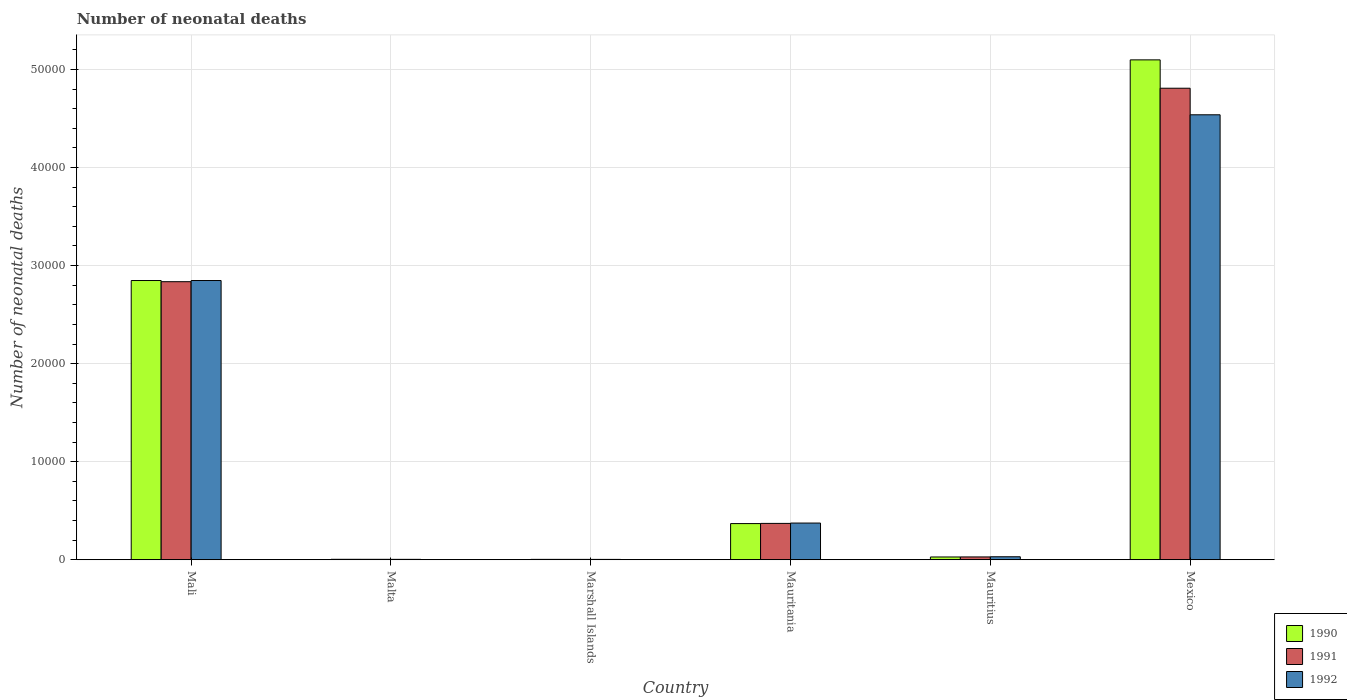How many groups of bars are there?
Your answer should be very brief. 6. Are the number of bars per tick equal to the number of legend labels?
Give a very brief answer. Yes. How many bars are there on the 2nd tick from the left?
Your answer should be very brief. 3. How many bars are there on the 4th tick from the right?
Ensure brevity in your answer.  3. What is the label of the 2nd group of bars from the left?
Give a very brief answer. Malta. In how many cases, is the number of bars for a given country not equal to the number of legend labels?
Make the answer very short. 0. What is the number of neonatal deaths in in 1991 in Malta?
Offer a terse response. 45. Across all countries, what is the maximum number of neonatal deaths in in 1990?
Offer a terse response. 5.10e+04. Across all countries, what is the minimum number of neonatal deaths in in 1991?
Keep it short and to the point. 39. In which country was the number of neonatal deaths in in 1991 minimum?
Make the answer very short. Marshall Islands. What is the total number of neonatal deaths in in 1992 in the graph?
Your response must be concise. 7.80e+04. What is the difference between the number of neonatal deaths in in 1991 in Marshall Islands and that in Mauritius?
Make the answer very short. -250. What is the difference between the number of neonatal deaths in in 1991 in Mali and the number of neonatal deaths in in 1990 in Mauritania?
Your response must be concise. 2.47e+04. What is the average number of neonatal deaths in in 1992 per country?
Provide a short and direct response. 1.30e+04. What is the difference between the number of neonatal deaths in of/in 1990 and number of neonatal deaths in of/in 1991 in Mauritania?
Keep it short and to the point. -19. What is the ratio of the number of neonatal deaths in in 1990 in Mali to that in Mauritius?
Provide a succinct answer. 99.92. Is the difference between the number of neonatal deaths in in 1990 in Mauritania and Mexico greater than the difference between the number of neonatal deaths in in 1991 in Mauritania and Mexico?
Your answer should be very brief. No. What is the difference between the highest and the second highest number of neonatal deaths in in 1992?
Give a very brief answer. 1.69e+04. What is the difference between the highest and the lowest number of neonatal deaths in in 1992?
Ensure brevity in your answer.  4.53e+04. In how many countries, is the number of neonatal deaths in in 1990 greater than the average number of neonatal deaths in in 1990 taken over all countries?
Keep it short and to the point. 2. What does the 3rd bar from the left in Marshall Islands represents?
Provide a succinct answer. 1992. Is it the case that in every country, the sum of the number of neonatal deaths in in 1991 and number of neonatal deaths in in 1990 is greater than the number of neonatal deaths in in 1992?
Your response must be concise. Yes. Are all the bars in the graph horizontal?
Give a very brief answer. No. What is the difference between two consecutive major ticks on the Y-axis?
Offer a terse response. 10000. Does the graph contain grids?
Offer a very short reply. Yes. Where does the legend appear in the graph?
Keep it short and to the point. Bottom right. How are the legend labels stacked?
Offer a very short reply. Vertical. What is the title of the graph?
Offer a very short reply. Number of neonatal deaths. What is the label or title of the Y-axis?
Your response must be concise. Number of neonatal deaths. What is the Number of neonatal deaths in 1990 in Mali?
Give a very brief answer. 2.85e+04. What is the Number of neonatal deaths of 1991 in Mali?
Give a very brief answer. 2.84e+04. What is the Number of neonatal deaths of 1992 in Mali?
Make the answer very short. 2.85e+04. What is the Number of neonatal deaths in 1992 in Malta?
Offer a very short reply. 42. What is the Number of neonatal deaths in 1990 in Marshall Islands?
Provide a short and direct response. 40. What is the Number of neonatal deaths in 1991 in Marshall Islands?
Provide a short and direct response. 39. What is the Number of neonatal deaths of 1990 in Mauritania?
Offer a very short reply. 3690. What is the Number of neonatal deaths of 1991 in Mauritania?
Keep it short and to the point. 3709. What is the Number of neonatal deaths in 1992 in Mauritania?
Provide a succinct answer. 3743. What is the Number of neonatal deaths of 1990 in Mauritius?
Your answer should be compact. 285. What is the Number of neonatal deaths in 1991 in Mauritius?
Your response must be concise. 289. What is the Number of neonatal deaths of 1992 in Mauritius?
Keep it short and to the point. 307. What is the Number of neonatal deaths in 1990 in Mexico?
Make the answer very short. 5.10e+04. What is the Number of neonatal deaths of 1991 in Mexico?
Offer a terse response. 4.81e+04. What is the Number of neonatal deaths in 1992 in Mexico?
Your answer should be compact. 4.54e+04. Across all countries, what is the maximum Number of neonatal deaths of 1990?
Ensure brevity in your answer.  5.10e+04. Across all countries, what is the maximum Number of neonatal deaths of 1991?
Your answer should be compact. 4.81e+04. Across all countries, what is the maximum Number of neonatal deaths in 1992?
Ensure brevity in your answer.  4.54e+04. Across all countries, what is the minimum Number of neonatal deaths in 1990?
Provide a succinct answer. 40. What is the total Number of neonatal deaths of 1990 in the graph?
Give a very brief answer. 8.35e+04. What is the total Number of neonatal deaths in 1991 in the graph?
Offer a very short reply. 8.05e+04. What is the total Number of neonatal deaths of 1992 in the graph?
Your response must be concise. 7.80e+04. What is the difference between the Number of neonatal deaths of 1990 in Mali and that in Malta?
Your response must be concise. 2.84e+04. What is the difference between the Number of neonatal deaths of 1991 in Mali and that in Malta?
Your answer should be compact. 2.83e+04. What is the difference between the Number of neonatal deaths in 1992 in Mali and that in Malta?
Provide a succinct answer. 2.84e+04. What is the difference between the Number of neonatal deaths in 1990 in Mali and that in Marshall Islands?
Provide a short and direct response. 2.84e+04. What is the difference between the Number of neonatal deaths of 1991 in Mali and that in Marshall Islands?
Ensure brevity in your answer.  2.83e+04. What is the difference between the Number of neonatal deaths in 1992 in Mali and that in Marshall Islands?
Your response must be concise. 2.84e+04. What is the difference between the Number of neonatal deaths in 1990 in Mali and that in Mauritania?
Offer a terse response. 2.48e+04. What is the difference between the Number of neonatal deaths in 1991 in Mali and that in Mauritania?
Provide a succinct answer. 2.46e+04. What is the difference between the Number of neonatal deaths in 1992 in Mali and that in Mauritania?
Give a very brief answer. 2.47e+04. What is the difference between the Number of neonatal deaths of 1990 in Mali and that in Mauritius?
Offer a very short reply. 2.82e+04. What is the difference between the Number of neonatal deaths of 1991 in Mali and that in Mauritius?
Offer a terse response. 2.81e+04. What is the difference between the Number of neonatal deaths in 1992 in Mali and that in Mauritius?
Make the answer very short. 2.82e+04. What is the difference between the Number of neonatal deaths of 1990 in Mali and that in Mexico?
Provide a short and direct response. -2.25e+04. What is the difference between the Number of neonatal deaths of 1991 in Mali and that in Mexico?
Provide a succinct answer. -1.97e+04. What is the difference between the Number of neonatal deaths in 1992 in Mali and that in Mexico?
Your answer should be very brief. -1.69e+04. What is the difference between the Number of neonatal deaths in 1991 in Malta and that in Marshall Islands?
Make the answer very short. 6. What is the difference between the Number of neonatal deaths in 1992 in Malta and that in Marshall Islands?
Your response must be concise. 4. What is the difference between the Number of neonatal deaths in 1990 in Malta and that in Mauritania?
Provide a succinct answer. -3643. What is the difference between the Number of neonatal deaths in 1991 in Malta and that in Mauritania?
Offer a terse response. -3664. What is the difference between the Number of neonatal deaths in 1992 in Malta and that in Mauritania?
Offer a very short reply. -3701. What is the difference between the Number of neonatal deaths of 1990 in Malta and that in Mauritius?
Ensure brevity in your answer.  -238. What is the difference between the Number of neonatal deaths in 1991 in Malta and that in Mauritius?
Ensure brevity in your answer.  -244. What is the difference between the Number of neonatal deaths of 1992 in Malta and that in Mauritius?
Your response must be concise. -265. What is the difference between the Number of neonatal deaths in 1990 in Malta and that in Mexico?
Provide a short and direct response. -5.09e+04. What is the difference between the Number of neonatal deaths in 1991 in Malta and that in Mexico?
Your answer should be very brief. -4.80e+04. What is the difference between the Number of neonatal deaths of 1992 in Malta and that in Mexico?
Your answer should be compact. -4.53e+04. What is the difference between the Number of neonatal deaths of 1990 in Marshall Islands and that in Mauritania?
Offer a terse response. -3650. What is the difference between the Number of neonatal deaths of 1991 in Marshall Islands and that in Mauritania?
Ensure brevity in your answer.  -3670. What is the difference between the Number of neonatal deaths in 1992 in Marshall Islands and that in Mauritania?
Provide a short and direct response. -3705. What is the difference between the Number of neonatal deaths in 1990 in Marshall Islands and that in Mauritius?
Your answer should be very brief. -245. What is the difference between the Number of neonatal deaths of 1991 in Marshall Islands and that in Mauritius?
Your response must be concise. -250. What is the difference between the Number of neonatal deaths of 1992 in Marshall Islands and that in Mauritius?
Give a very brief answer. -269. What is the difference between the Number of neonatal deaths in 1990 in Marshall Islands and that in Mexico?
Your response must be concise. -5.09e+04. What is the difference between the Number of neonatal deaths in 1991 in Marshall Islands and that in Mexico?
Make the answer very short. -4.80e+04. What is the difference between the Number of neonatal deaths in 1992 in Marshall Islands and that in Mexico?
Your answer should be very brief. -4.53e+04. What is the difference between the Number of neonatal deaths in 1990 in Mauritania and that in Mauritius?
Offer a very short reply. 3405. What is the difference between the Number of neonatal deaths in 1991 in Mauritania and that in Mauritius?
Provide a short and direct response. 3420. What is the difference between the Number of neonatal deaths of 1992 in Mauritania and that in Mauritius?
Keep it short and to the point. 3436. What is the difference between the Number of neonatal deaths of 1990 in Mauritania and that in Mexico?
Keep it short and to the point. -4.73e+04. What is the difference between the Number of neonatal deaths in 1991 in Mauritania and that in Mexico?
Your answer should be very brief. -4.44e+04. What is the difference between the Number of neonatal deaths in 1992 in Mauritania and that in Mexico?
Give a very brief answer. -4.16e+04. What is the difference between the Number of neonatal deaths of 1990 in Mauritius and that in Mexico?
Ensure brevity in your answer.  -5.07e+04. What is the difference between the Number of neonatal deaths of 1991 in Mauritius and that in Mexico?
Your answer should be compact. -4.78e+04. What is the difference between the Number of neonatal deaths of 1992 in Mauritius and that in Mexico?
Make the answer very short. -4.51e+04. What is the difference between the Number of neonatal deaths in 1990 in Mali and the Number of neonatal deaths in 1991 in Malta?
Offer a terse response. 2.84e+04. What is the difference between the Number of neonatal deaths in 1990 in Mali and the Number of neonatal deaths in 1992 in Malta?
Your response must be concise. 2.84e+04. What is the difference between the Number of neonatal deaths in 1991 in Mali and the Number of neonatal deaths in 1992 in Malta?
Provide a short and direct response. 2.83e+04. What is the difference between the Number of neonatal deaths of 1990 in Mali and the Number of neonatal deaths of 1991 in Marshall Islands?
Your answer should be compact. 2.84e+04. What is the difference between the Number of neonatal deaths in 1990 in Mali and the Number of neonatal deaths in 1992 in Marshall Islands?
Ensure brevity in your answer.  2.84e+04. What is the difference between the Number of neonatal deaths of 1991 in Mali and the Number of neonatal deaths of 1992 in Marshall Islands?
Make the answer very short. 2.83e+04. What is the difference between the Number of neonatal deaths in 1990 in Mali and the Number of neonatal deaths in 1991 in Mauritania?
Provide a short and direct response. 2.48e+04. What is the difference between the Number of neonatal deaths of 1990 in Mali and the Number of neonatal deaths of 1992 in Mauritania?
Provide a succinct answer. 2.47e+04. What is the difference between the Number of neonatal deaths in 1991 in Mali and the Number of neonatal deaths in 1992 in Mauritania?
Provide a succinct answer. 2.46e+04. What is the difference between the Number of neonatal deaths of 1990 in Mali and the Number of neonatal deaths of 1991 in Mauritius?
Provide a short and direct response. 2.82e+04. What is the difference between the Number of neonatal deaths of 1990 in Mali and the Number of neonatal deaths of 1992 in Mauritius?
Make the answer very short. 2.82e+04. What is the difference between the Number of neonatal deaths of 1991 in Mali and the Number of neonatal deaths of 1992 in Mauritius?
Your answer should be very brief. 2.81e+04. What is the difference between the Number of neonatal deaths of 1990 in Mali and the Number of neonatal deaths of 1991 in Mexico?
Give a very brief answer. -1.96e+04. What is the difference between the Number of neonatal deaths in 1990 in Mali and the Number of neonatal deaths in 1992 in Mexico?
Your response must be concise. -1.69e+04. What is the difference between the Number of neonatal deaths in 1991 in Mali and the Number of neonatal deaths in 1992 in Mexico?
Offer a terse response. -1.70e+04. What is the difference between the Number of neonatal deaths in 1990 in Malta and the Number of neonatal deaths in 1991 in Marshall Islands?
Your response must be concise. 8. What is the difference between the Number of neonatal deaths of 1990 in Malta and the Number of neonatal deaths of 1992 in Marshall Islands?
Your answer should be compact. 9. What is the difference between the Number of neonatal deaths of 1990 in Malta and the Number of neonatal deaths of 1991 in Mauritania?
Your answer should be very brief. -3662. What is the difference between the Number of neonatal deaths of 1990 in Malta and the Number of neonatal deaths of 1992 in Mauritania?
Give a very brief answer. -3696. What is the difference between the Number of neonatal deaths in 1991 in Malta and the Number of neonatal deaths in 1992 in Mauritania?
Offer a very short reply. -3698. What is the difference between the Number of neonatal deaths in 1990 in Malta and the Number of neonatal deaths in 1991 in Mauritius?
Your response must be concise. -242. What is the difference between the Number of neonatal deaths in 1990 in Malta and the Number of neonatal deaths in 1992 in Mauritius?
Your response must be concise. -260. What is the difference between the Number of neonatal deaths in 1991 in Malta and the Number of neonatal deaths in 1992 in Mauritius?
Give a very brief answer. -262. What is the difference between the Number of neonatal deaths of 1990 in Malta and the Number of neonatal deaths of 1991 in Mexico?
Provide a short and direct response. -4.80e+04. What is the difference between the Number of neonatal deaths in 1990 in Malta and the Number of neonatal deaths in 1992 in Mexico?
Provide a short and direct response. -4.53e+04. What is the difference between the Number of neonatal deaths of 1991 in Malta and the Number of neonatal deaths of 1992 in Mexico?
Offer a terse response. -4.53e+04. What is the difference between the Number of neonatal deaths of 1990 in Marshall Islands and the Number of neonatal deaths of 1991 in Mauritania?
Provide a short and direct response. -3669. What is the difference between the Number of neonatal deaths in 1990 in Marshall Islands and the Number of neonatal deaths in 1992 in Mauritania?
Provide a short and direct response. -3703. What is the difference between the Number of neonatal deaths of 1991 in Marshall Islands and the Number of neonatal deaths of 1992 in Mauritania?
Offer a terse response. -3704. What is the difference between the Number of neonatal deaths in 1990 in Marshall Islands and the Number of neonatal deaths in 1991 in Mauritius?
Your response must be concise. -249. What is the difference between the Number of neonatal deaths in 1990 in Marshall Islands and the Number of neonatal deaths in 1992 in Mauritius?
Provide a short and direct response. -267. What is the difference between the Number of neonatal deaths of 1991 in Marshall Islands and the Number of neonatal deaths of 1992 in Mauritius?
Ensure brevity in your answer.  -268. What is the difference between the Number of neonatal deaths in 1990 in Marshall Islands and the Number of neonatal deaths in 1991 in Mexico?
Make the answer very short. -4.80e+04. What is the difference between the Number of neonatal deaths of 1990 in Marshall Islands and the Number of neonatal deaths of 1992 in Mexico?
Provide a succinct answer. -4.53e+04. What is the difference between the Number of neonatal deaths in 1991 in Marshall Islands and the Number of neonatal deaths in 1992 in Mexico?
Give a very brief answer. -4.53e+04. What is the difference between the Number of neonatal deaths in 1990 in Mauritania and the Number of neonatal deaths in 1991 in Mauritius?
Offer a terse response. 3401. What is the difference between the Number of neonatal deaths of 1990 in Mauritania and the Number of neonatal deaths of 1992 in Mauritius?
Provide a short and direct response. 3383. What is the difference between the Number of neonatal deaths in 1991 in Mauritania and the Number of neonatal deaths in 1992 in Mauritius?
Your response must be concise. 3402. What is the difference between the Number of neonatal deaths of 1990 in Mauritania and the Number of neonatal deaths of 1991 in Mexico?
Your response must be concise. -4.44e+04. What is the difference between the Number of neonatal deaths in 1990 in Mauritania and the Number of neonatal deaths in 1992 in Mexico?
Keep it short and to the point. -4.17e+04. What is the difference between the Number of neonatal deaths in 1991 in Mauritania and the Number of neonatal deaths in 1992 in Mexico?
Your answer should be compact. -4.17e+04. What is the difference between the Number of neonatal deaths in 1990 in Mauritius and the Number of neonatal deaths in 1991 in Mexico?
Your response must be concise. -4.78e+04. What is the difference between the Number of neonatal deaths of 1990 in Mauritius and the Number of neonatal deaths of 1992 in Mexico?
Ensure brevity in your answer.  -4.51e+04. What is the difference between the Number of neonatal deaths of 1991 in Mauritius and the Number of neonatal deaths of 1992 in Mexico?
Provide a short and direct response. -4.51e+04. What is the average Number of neonatal deaths in 1990 per country?
Provide a short and direct response. 1.39e+04. What is the average Number of neonatal deaths of 1991 per country?
Your response must be concise. 1.34e+04. What is the average Number of neonatal deaths of 1992 per country?
Give a very brief answer. 1.30e+04. What is the difference between the Number of neonatal deaths of 1990 and Number of neonatal deaths of 1991 in Mali?
Ensure brevity in your answer.  120. What is the difference between the Number of neonatal deaths in 1990 and Number of neonatal deaths in 1992 in Mali?
Your answer should be very brief. 0. What is the difference between the Number of neonatal deaths of 1991 and Number of neonatal deaths of 1992 in Mali?
Ensure brevity in your answer.  -120. What is the difference between the Number of neonatal deaths of 1990 and Number of neonatal deaths of 1991 in Malta?
Offer a terse response. 2. What is the difference between the Number of neonatal deaths in 1990 and Number of neonatal deaths in 1992 in Malta?
Your response must be concise. 5. What is the difference between the Number of neonatal deaths of 1990 and Number of neonatal deaths of 1991 in Marshall Islands?
Make the answer very short. 1. What is the difference between the Number of neonatal deaths of 1990 and Number of neonatal deaths of 1991 in Mauritania?
Make the answer very short. -19. What is the difference between the Number of neonatal deaths in 1990 and Number of neonatal deaths in 1992 in Mauritania?
Your answer should be very brief. -53. What is the difference between the Number of neonatal deaths of 1991 and Number of neonatal deaths of 1992 in Mauritania?
Your answer should be compact. -34. What is the difference between the Number of neonatal deaths in 1990 and Number of neonatal deaths in 1991 in Mauritius?
Offer a terse response. -4. What is the difference between the Number of neonatal deaths in 1990 and Number of neonatal deaths in 1992 in Mauritius?
Give a very brief answer. -22. What is the difference between the Number of neonatal deaths of 1991 and Number of neonatal deaths of 1992 in Mauritius?
Your answer should be very brief. -18. What is the difference between the Number of neonatal deaths in 1990 and Number of neonatal deaths in 1991 in Mexico?
Your answer should be compact. 2892. What is the difference between the Number of neonatal deaths in 1990 and Number of neonatal deaths in 1992 in Mexico?
Provide a succinct answer. 5601. What is the difference between the Number of neonatal deaths of 1991 and Number of neonatal deaths of 1992 in Mexico?
Keep it short and to the point. 2709. What is the ratio of the Number of neonatal deaths in 1990 in Mali to that in Malta?
Keep it short and to the point. 605.91. What is the ratio of the Number of neonatal deaths of 1991 in Mali to that in Malta?
Make the answer very short. 630.18. What is the ratio of the Number of neonatal deaths of 1992 in Mali to that in Malta?
Offer a terse response. 678.05. What is the ratio of the Number of neonatal deaths of 1990 in Mali to that in Marshall Islands?
Your answer should be very brief. 711.95. What is the ratio of the Number of neonatal deaths in 1991 in Mali to that in Marshall Islands?
Your answer should be compact. 727.13. What is the ratio of the Number of neonatal deaths of 1992 in Mali to that in Marshall Islands?
Keep it short and to the point. 749.42. What is the ratio of the Number of neonatal deaths in 1990 in Mali to that in Mauritania?
Ensure brevity in your answer.  7.72. What is the ratio of the Number of neonatal deaths of 1991 in Mali to that in Mauritania?
Give a very brief answer. 7.65. What is the ratio of the Number of neonatal deaths in 1992 in Mali to that in Mauritania?
Offer a terse response. 7.61. What is the ratio of the Number of neonatal deaths of 1990 in Mali to that in Mauritius?
Your answer should be compact. 99.92. What is the ratio of the Number of neonatal deaths in 1991 in Mali to that in Mauritius?
Give a very brief answer. 98.12. What is the ratio of the Number of neonatal deaths of 1992 in Mali to that in Mauritius?
Offer a very short reply. 92.76. What is the ratio of the Number of neonatal deaths in 1990 in Mali to that in Mexico?
Offer a terse response. 0.56. What is the ratio of the Number of neonatal deaths in 1991 in Mali to that in Mexico?
Keep it short and to the point. 0.59. What is the ratio of the Number of neonatal deaths in 1992 in Mali to that in Mexico?
Offer a very short reply. 0.63. What is the ratio of the Number of neonatal deaths of 1990 in Malta to that in Marshall Islands?
Give a very brief answer. 1.18. What is the ratio of the Number of neonatal deaths in 1991 in Malta to that in Marshall Islands?
Your answer should be very brief. 1.15. What is the ratio of the Number of neonatal deaths in 1992 in Malta to that in Marshall Islands?
Your answer should be compact. 1.11. What is the ratio of the Number of neonatal deaths of 1990 in Malta to that in Mauritania?
Make the answer very short. 0.01. What is the ratio of the Number of neonatal deaths of 1991 in Malta to that in Mauritania?
Make the answer very short. 0.01. What is the ratio of the Number of neonatal deaths of 1992 in Malta to that in Mauritania?
Give a very brief answer. 0.01. What is the ratio of the Number of neonatal deaths in 1990 in Malta to that in Mauritius?
Your response must be concise. 0.16. What is the ratio of the Number of neonatal deaths in 1991 in Malta to that in Mauritius?
Offer a very short reply. 0.16. What is the ratio of the Number of neonatal deaths of 1992 in Malta to that in Mauritius?
Your answer should be compact. 0.14. What is the ratio of the Number of neonatal deaths of 1990 in Malta to that in Mexico?
Your answer should be very brief. 0. What is the ratio of the Number of neonatal deaths of 1991 in Malta to that in Mexico?
Make the answer very short. 0. What is the ratio of the Number of neonatal deaths of 1992 in Malta to that in Mexico?
Your answer should be compact. 0. What is the ratio of the Number of neonatal deaths in 1990 in Marshall Islands to that in Mauritania?
Your answer should be compact. 0.01. What is the ratio of the Number of neonatal deaths in 1991 in Marshall Islands to that in Mauritania?
Your response must be concise. 0.01. What is the ratio of the Number of neonatal deaths in 1992 in Marshall Islands to that in Mauritania?
Your answer should be very brief. 0.01. What is the ratio of the Number of neonatal deaths of 1990 in Marshall Islands to that in Mauritius?
Provide a succinct answer. 0.14. What is the ratio of the Number of neonatal deaths of 1991 in Marshall Islands to that in Mauritius?
Provide a succinct answer. 0.13. What is the ratio of the Number of neonatal deaths of 1992 in Marshall Islands to that in Mauritius?
Keep it short and to the point. 0.12. What is the ratio of the Number of neonatal deaths in 1990 in Marshall Islands to that in Mexico?
Your answer should be compact. 0. What is the ratio of the Number of neonatal deaths of 1991 in Marshall Islands to that in Mexico?
Make the answer very short. 0. What is the ratio of the Number of neonatal deaths in 1992 in Marshall Islands to that in Mexico?
Provide a succinct answer. 0. What is the ratio of the Number of neonatal deaths in 1990 in Mauritania to that in Mauritius?
Give a very brief answer. 12.95. What is the ratio of the Number of neonatal deaths in 1991 in Mauritania to that in Mauritius?
Make the answer very short. 12.83. What is the ratio of the Number of neonatal deaths of 1992 in Mauritania to that in Mauritius?
Your answer should be very brief. 12.19. What is the ratio of the Number of neonatal deaths in 1990 in Mauritania to that in Mexico?
Your response must be concise. 0.07. What is the ratio of the Number of neonatal deaths in 1991 in Mauritania to that in Mexico?
Your answer should be very brief. 0.08. What is the ratio of the Number of neonatal deaths of 1992 in Mauritania to that in Mexico?
Ensure brevity in your answer.  0.08. What is the ratio of the Number of neonatal deaths in 1990 in Mauritius to that in Mexico?
Offer a terse response. 0.01. What is the ratio of the Number of neonatal deaths of 1991 in Mauritius to that in Mexico?
Your response must be concise. 0.01. What is the ratio of the Number of neonatal deaths of 1992 in Mauritius to that in Mexico?
Keep it short and to the point. 0.01. What is the difference between the highest and the second highest Number of neonatal deaths in 1990?
Ensure brevity in your answer.  2.25e+04. What is the difference between the highest and the second highest Number of neonatal deaths in 1991?
Offer a very short reply. 1.97e+04. What is the difference between the highest and the second highest Number of neonatal deaths of 1992?
Provide a short and direct response. 1.69e+04. What is the difference between the highest and the lowest Number of neonatal deaths in 1990?
Provide a short and direct response. 5.09e+04. What is the difference between the highest and the lowest Number of neonatal deaths in 1991?
Your answer should be compact. 4.80e+04. What is the difference between the highest and the lowest Number of neonatal deaths in 1992?
Offer a very short reply. 4.53e+04. 